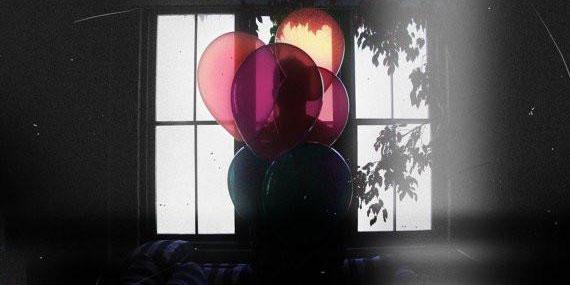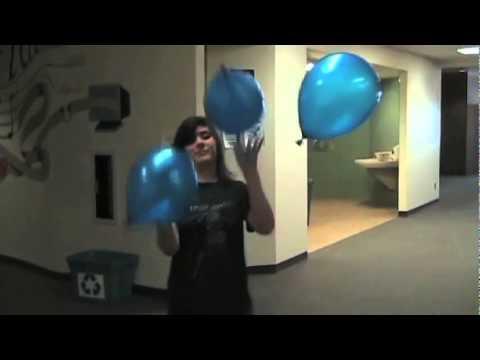The first image is the image on the left, the second image is the image on the right. Assess this claim about the two images: "The image on the right contains at least one blue balloon.". Correct or not? Answer yes or no. Yes. The first image is the image on the left, the second image is the image on the right. Given the left and right images, does the statement "One image shows exactly one human interacting with a single balloon in what could be a science demonstration, while the other image shows exactly three balloons." hold true? Answer yes or no. No. 